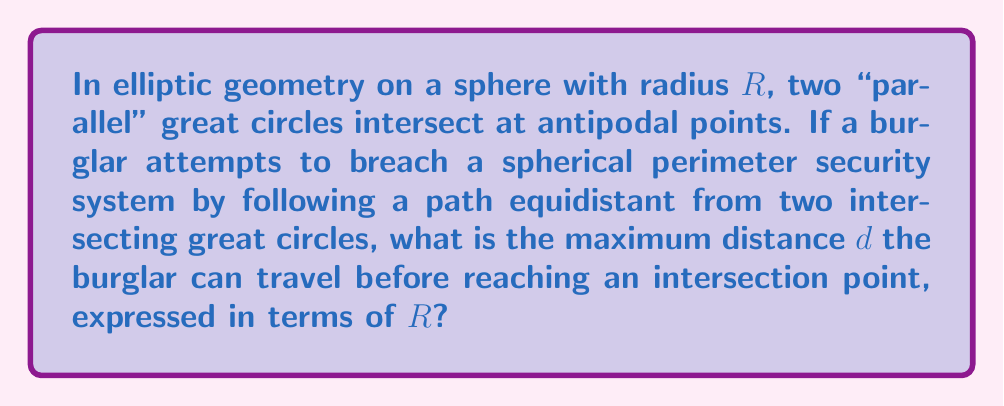Could you help me with this problem? Let's approach this step-by-step:

1) In elliptic geometry on a sphere, "parallel" lines are great circles that intersect at antipodal points.

2) The path equidistant from two intersecting great circles forms another great circle, perpendicular to both.

3) The angle between two great circles at their intersection is the same as the angle between their poles.

4) The poles of two intersecting great circles form a spherical right triangle with the intersection point.

5) In this spherical right triangle:
   - One vertex is at the pole of the first great circle
   - The second vertex is at the pole of the second great circle
   - The third vertex is at the intersection of the two great circles

6) The side opposite to the right angle in this spherical triangle is a quadrant of a great circle, which has length $\frac{\pi R}{2}$.

7) The burglar's path starts at one intersection point and ends at the antipodal intersection point, which is half of a great circle.

8) Therefore, the maximum distance $d$ the burglar can travel is half the circumference of a great circle:

   $$d = \frac{1}{2} \cdot 2\pi R = \pi R$$

This distance represents the longest path the burglar can take before encountering an intersection point of the two "parallel" great circles.
Answer: $\pi R$ 